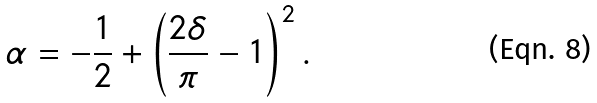Convert formula to latex. <formula><loc_0><loc_0><loc_500><loc_500>\alpha = - \frac { 1 } { 2 } + \left ( \frac { 2 \delta } { \pi } - 1 \right ) ^ { 2 } .</formula> 